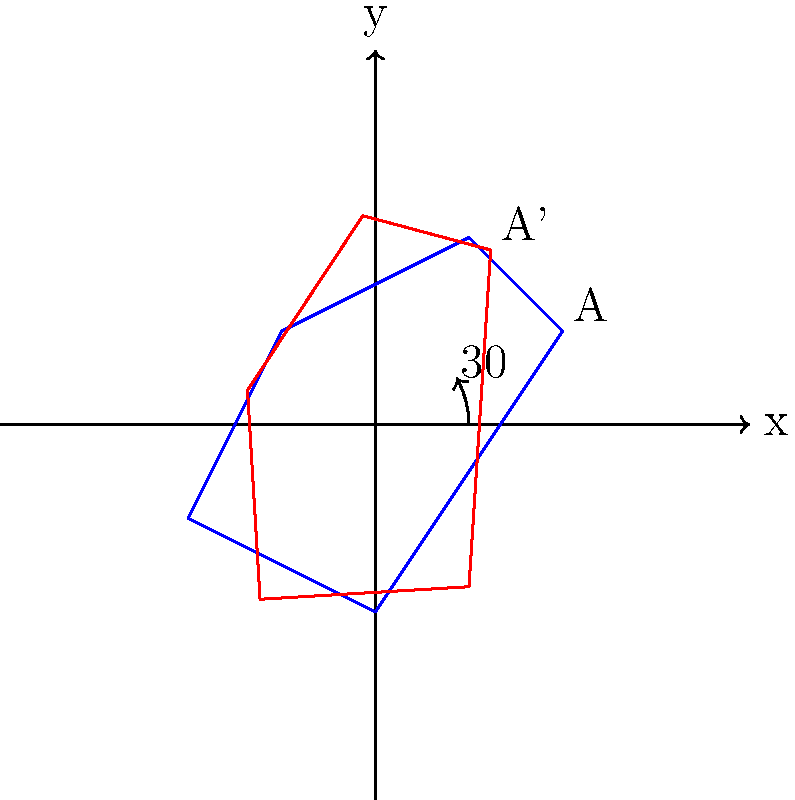As a history professor working on aligning historical maps with modern coordinates, you need to rotate a map by 30° counterclockwise to match current geographical alignments. Given that point A on the original map has coordinates (1, 0.5), what are the coordinates of point A' on the rotated map? Use the rotation matrix to calculate your answer and round to two decimal places. To solve this problem, we'll use the rotation matrix for a counterclockwise rotation of 30°. The steps are as follows:

1. Recall the rotation matrix for a counterclockwise rotation by angle θ:
   $$R(\theta) = \begin{pmatrix} \cos\theta & -\sin\theta \\ \sin\theta & \cos\theta \end{pmatrix}$$

2. For a 30° rotation, we have:
   $$R(30°) = \begin{pmatrix} \cos30° & -\sin30° \\ \sin30° & \cos30° \end{pmatrix}$$

3. Calculate the values (rounded to 4 decimal places):
   $$R(30°) = \begin{pmatrix} 0.8660 & -0.5000 \\ 0.5000 & 0.8660 \end{pmatrix}$$

4. To find the new coordinates, multiply the rotation matrix by the original coordinates:
   $$\begin{pmatrix} x' \\ y' \end{pmatrix} = \begin{pmatrix} 0.8660 & -0.5000 \\ 0.5000 & 0.8660 \end{pmatrix} \begin{pmatrix} 1 \\ 0.5 \end{pmatrix}$$

5. Perform the matrix multiplication:
   $$\begin{pmatrix} x' \\ y' \end{pmatrix} = \begin{pmatrix} (0.8660 \times 1) + (-0.5000 \times 0.5) \\ (0.5000 \times 1) + (0.8660 \times 0.5) \end{pmatrix}$$

6. Calculate the results:
   $$\begin{pmatrix} x' \\ y' \end{pmatrix} = \begin{pmatrix} 0.8660 - 0.2500 \\ 0.5000 + 0.4330 \end{pmatrix} = \begin{pmatrix} 0.6160 \\ 0.9330 \end{pmatrix}$$

7. Round to two decimal places:
   $$\begin{pmatrix} x' \\ y' \end{pmatrix} = \begin{pmatrix} 0.62 \\ 0.93 \end{pmatrix}$$

Therefore, the coordinates of point A' on the rotated map are (0.62, 0.93).
Answer: (0.62, 0.93) 